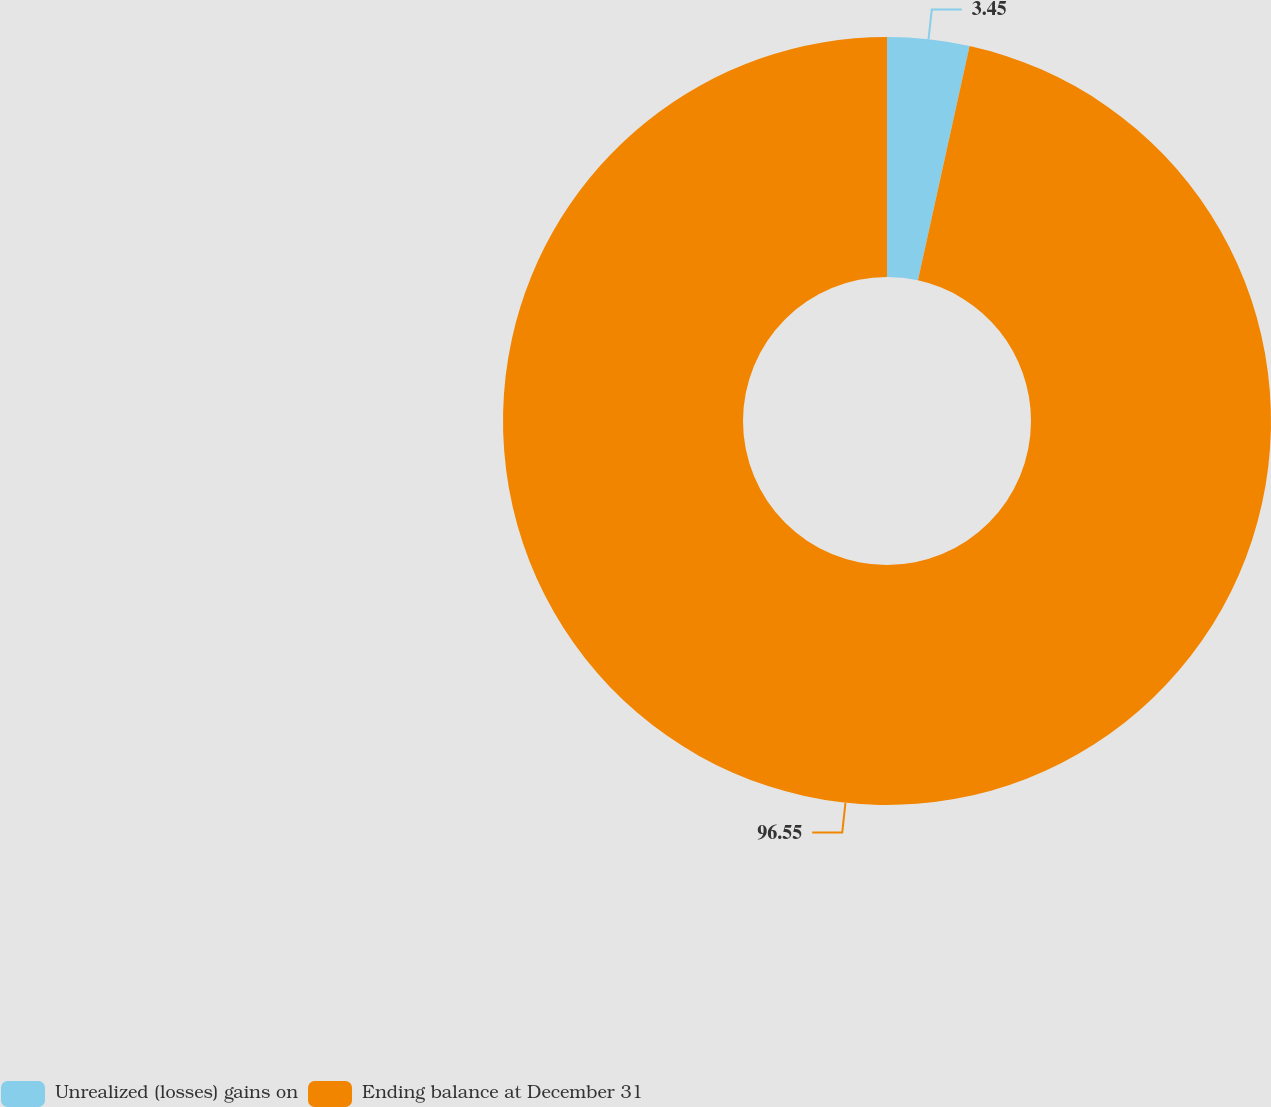<chart> <loc_0><loc_0><loc_500><loc_500><pie_chart><fcel>Unrealized (losses) gains on<fcel>Ending balance at December 31<nl><fcel>3.45%<fcel>96.55%<nl></chart> 